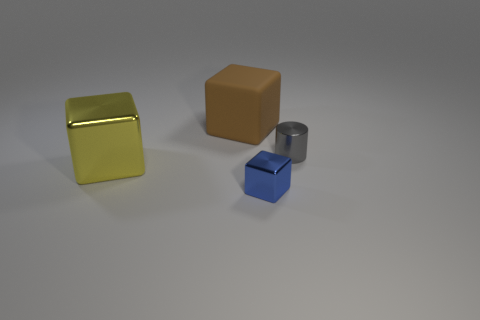Is the material of the large object that is on the left side of the rubber thing the same as the big brown object?
Your answer should be very brief. No. Do the object that is on the left side of the brown object and the big object that is behind the big metallic thing have the same material?
Ensure brevity in your answer.  No. Is there another thing that has the same size as the blue object?
Provide a succinct answer. Yes. Are there fewer blue blocks than large brown metallic objects?
Provide a short and direct response. No. How many blocks are either yellow shiny objects or big matte things?
Your answer should be compact. 2. What number of other metal cylinders are the same color as the tiny cylinder?
Your response must be concise. 0. There is a metallic object that is behind the tiny blue shiny object and on the right side of the brown block; what size is it?
Your response must be concise. Small. Is the number of yellow shiny cubes that are on the right side of the blue metallic block less than the number of big objects?
Make the answer very short. Yes. Are the large brown thing and the tiny blue cube made of the same material?
Offer a very short reply. No. How many things are cyan cubes or tiny shiny cubes?
Your response must be concise. 1. 